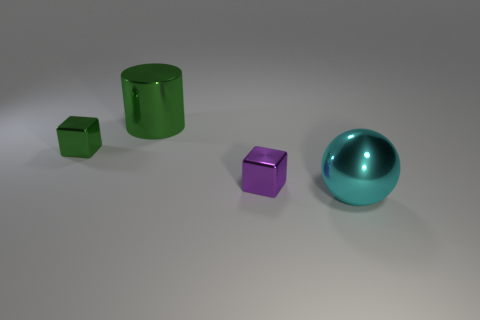Subtract all cylinders. How many objects are left? 3 Subtract 1 cylinders. How many cylinders are left? 0 Subtract all yellow cubes. Subtract all gray cylinders. How many cubes are left? 2 Subtract all yellow spheres. How many green blocks are left? 1 Subtract all tiny purple cubes. Subtract all large metallic spheres. How many objects are left? 2 Add 2 purple metal things. How many purple metal things are left? 3 Add 3 green metallic cylinders. How many green metallic cylinders exist? 4 Add 3 green objects. How many objects exist? 7 Subtract all purple blocks. How many blocks are left? 1 Subtract 0 brown balls. How many objects are left? 4 